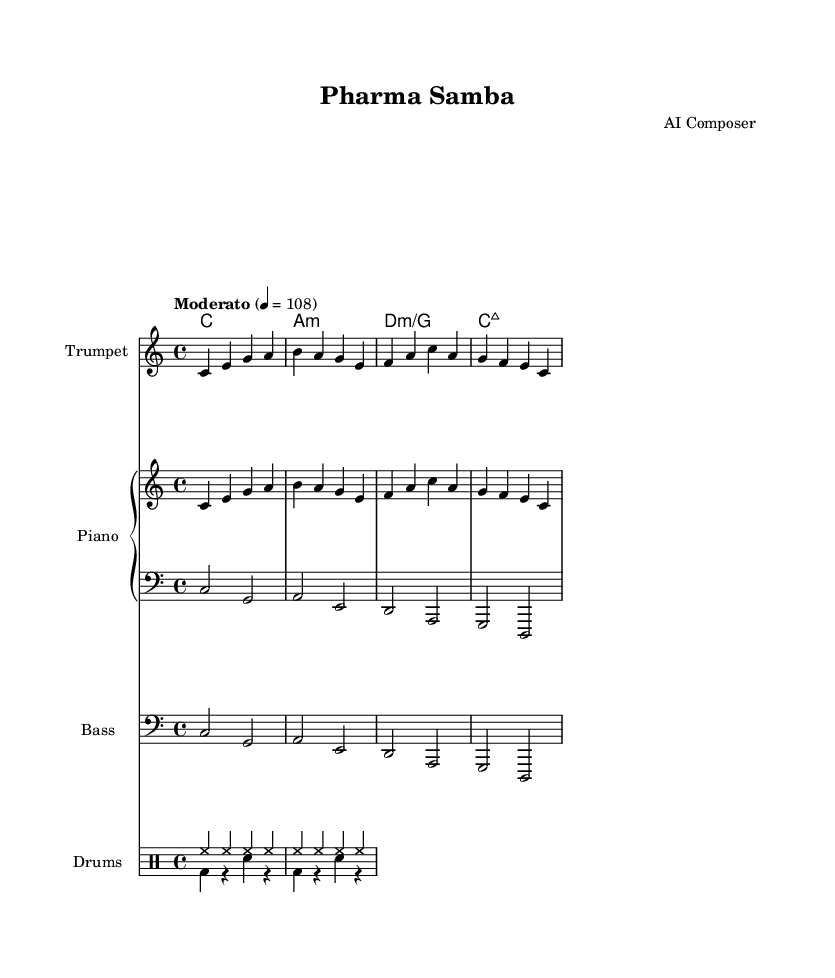What is the key signature of this music? The key signature is C major, which has no sharps or flats indicated in the music.
Answer: C major What is the time signature of this piece? The time signature is 4/4, as seen at the beginning of the staff where it specifies the number of beats per measure.
Answer: 4/4 What is the tempo marking? The tempo marking is "Moderato" with a metronome marking of 108 beats per minute, noted at the start of the score.
Answer: Moderato 4 = 108 How many bars are in the melody line? The melody line consists of four bars, counting each bar's vertical line in the notation.
Answer: Four What is the relationship between the first chord and the melody note in bar one? The first chord is C major, and the melody begins with the note C, suggesting that the melody starts on the root note of the chord.
Answer: Root note Which instrument plays the drum patterns in this piece? The drum patterns are played by the "Drums" staff, which typically includes multiple percussion voices as indicated.
Answer: Drums What type of jazz does this music represent? This music represents sophisticated Latin jazz, characterized by the rhythmic and harmonic complexities typical of the genre.
Answer: Latin jazz 